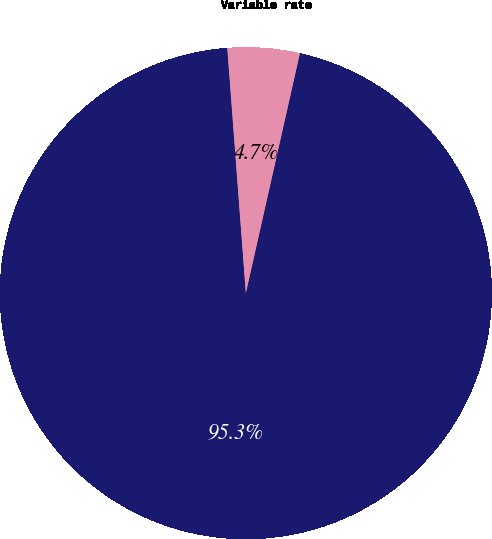<chart> <loc_0><loc_0><loc_500><loc_500><pie_chart><fcel>Fixed rate<fcel>Variable rate<nl><fcel>95.27%<fcel>4.73%<nl></chart> 